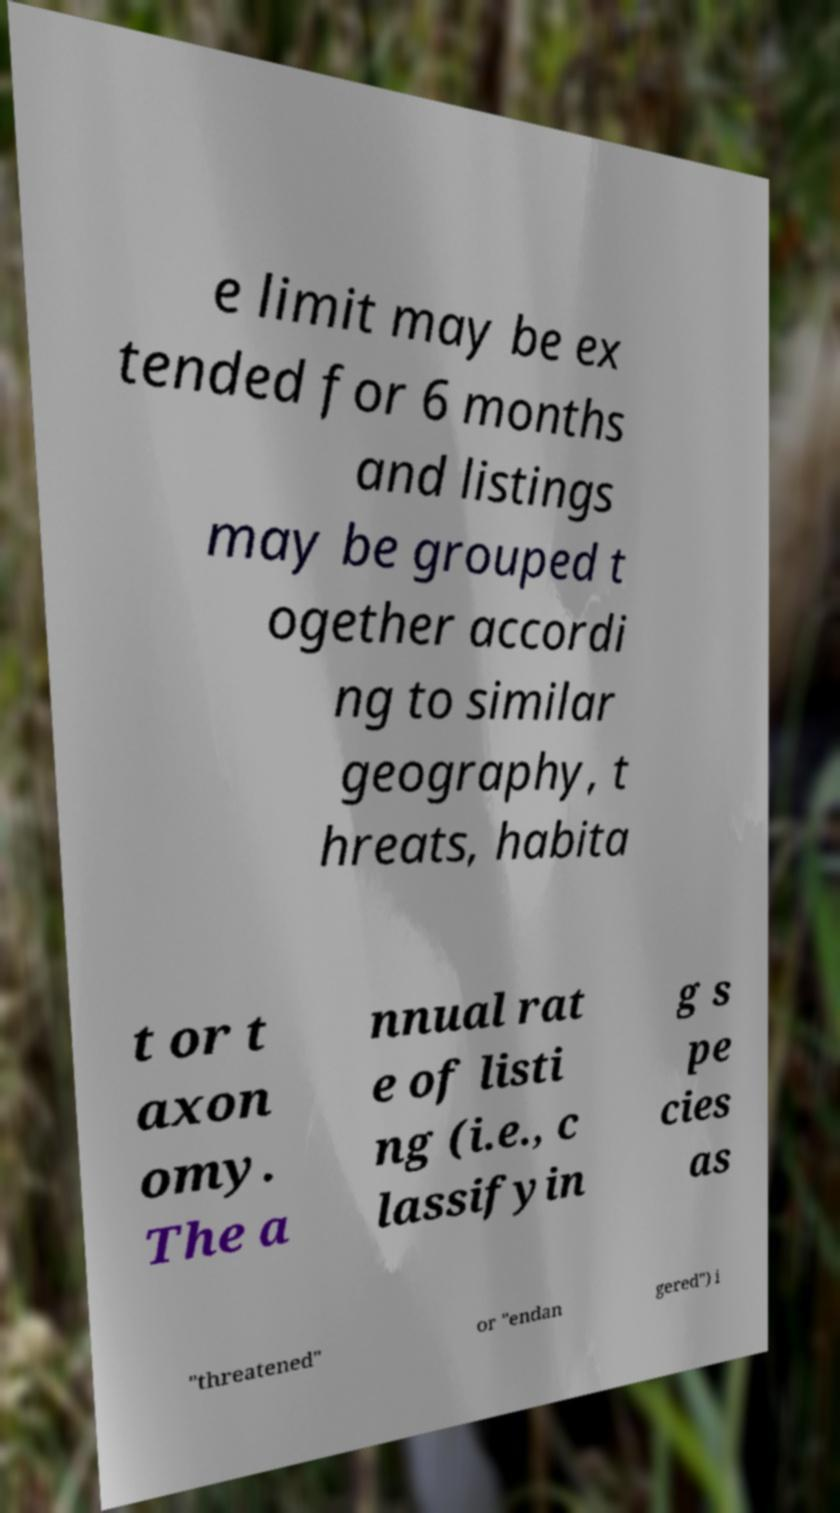Can you read and provide the text displayed in the image?This photo seems to have some interesting text. Can you extract and type it out for me? e limit may be ex tended for 6 months and listings may be grouped t ogether accordi ng to similar geography, t hreats, habita t or t axon omy. The a nnual rat e of listi ng (i.e., c lassifyin g s pe cies as "threatened" or "endan gered") i 